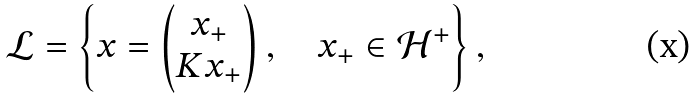<formula> <loc_0><loc_0><loc_500><loc_500>\mathcal { L } = \left \{ x = \begin{pmatrix} x _ { + } \\ K x _ { + } \end{pmatrix} , \quad x _ { + } \in \mathcal { H } ^ { + } \right \} ,</formula> 